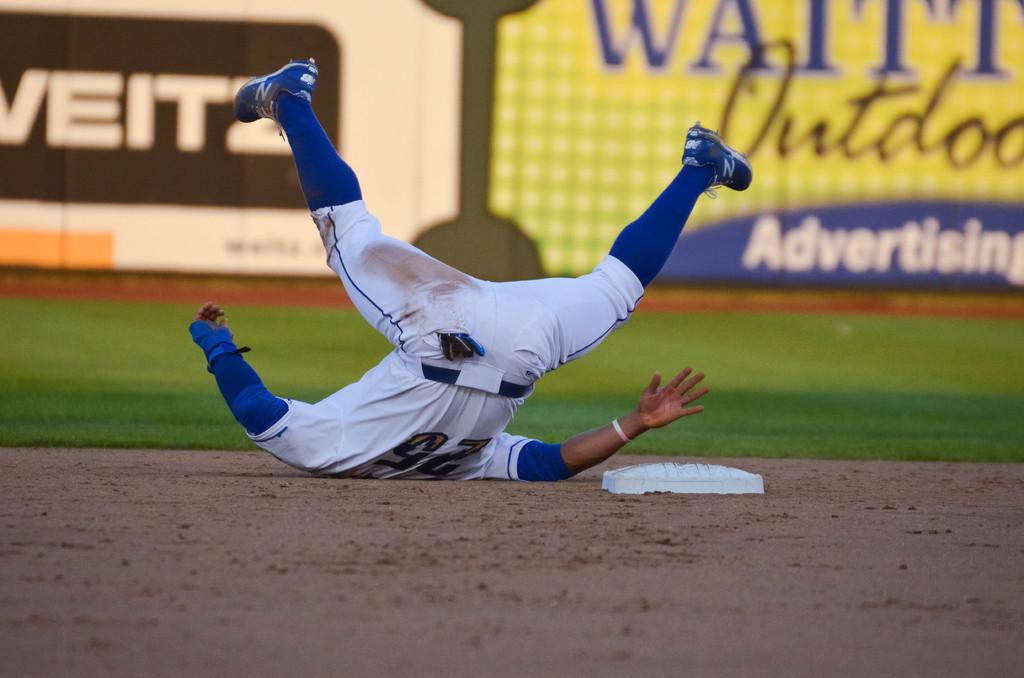<image>
Summarize the visual content of the image. Baseball player that tumbled over near one of the bases, he is # 25. 